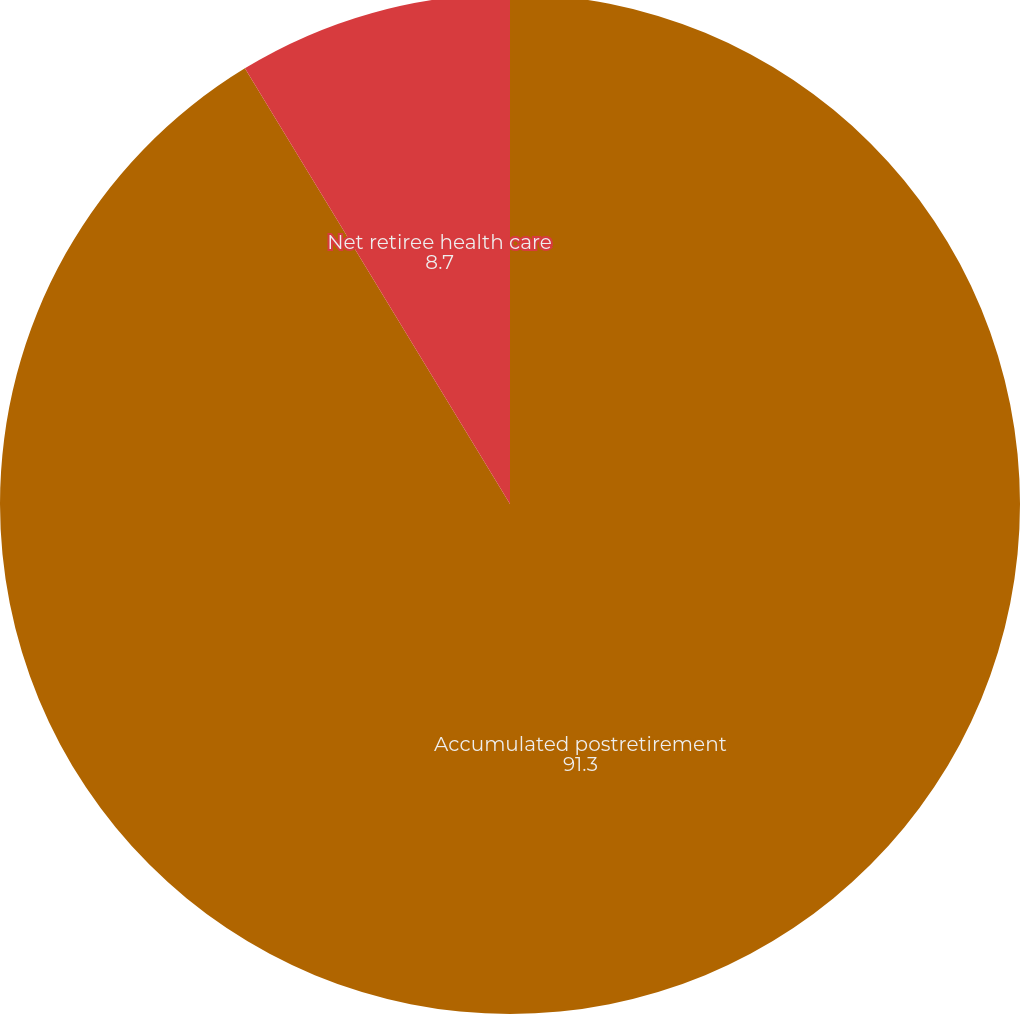Convert chart. <chart><loc_0><loc_0><loc_500><loc_500><pie_chart><fcel>Accumulated postretirement<fcel>Net retiree health care<nl><fcel>91.3%<fcel>8.7%<nl></chart> 